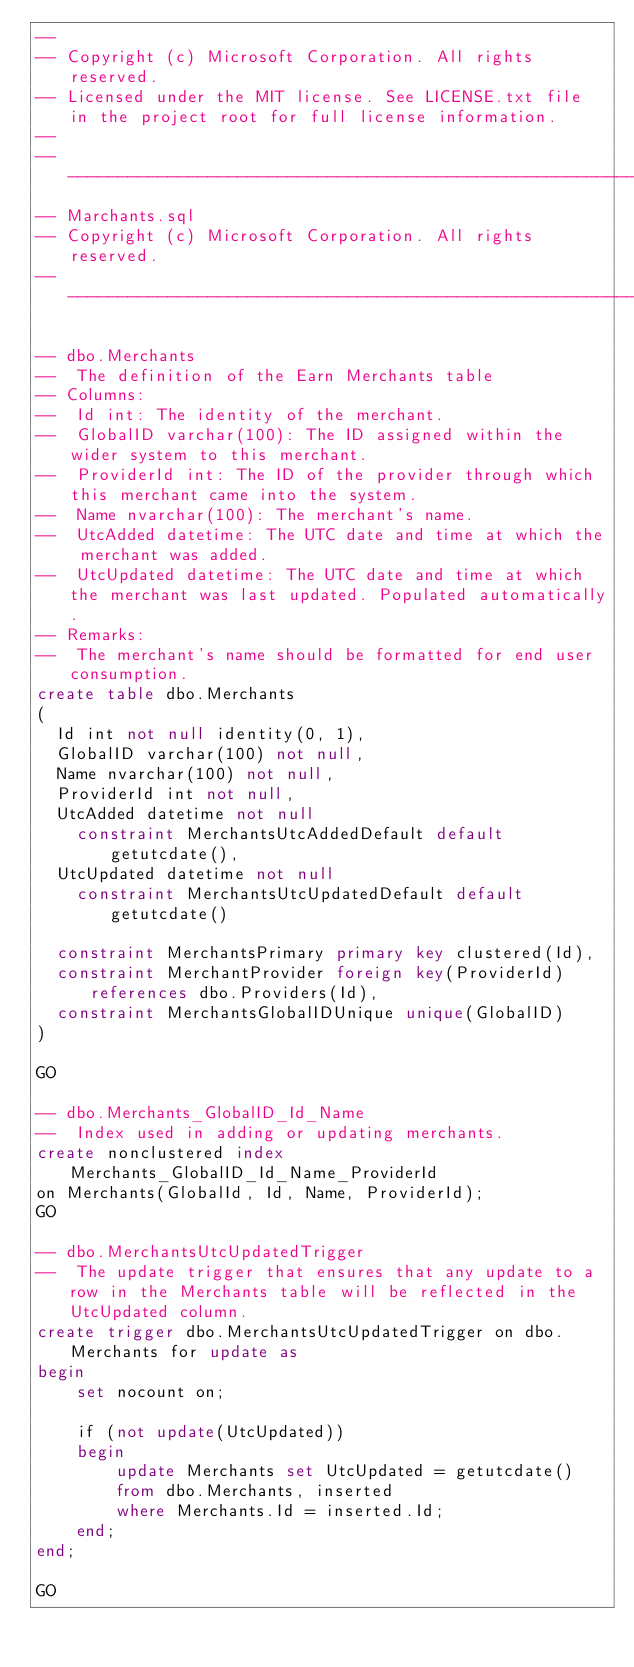Convert code to text. <code><loc_0><loc_0><loc_500><loc_500><_SQL_>--
-- Copyright (c) Microsoft Corporation. All rights reserved. 
-- Licensed under the MIT license. See LICENSE.txt file in the project root for full license information.
--
---------------------------------------------------------------------------------------------------------------------------------
-- Marchants.sql
-- Copyright (c) Microsoft Corporation. All rights reserved.  
---------------------------------------------------------------------------------------------------------------------------------

-- dbo.Merchants
--  The definition of the Earn Merchants table
-- Columns:
--  Id int: The identity of the merchant.
--  GlobalID varchar(100): The ID assigned within the wider system to this merchant.
--  ProviderId int: The ID of the provider through which this merchant came into the system.
--  Name nvarchar(100): The merchant's name.
--  UtcAdded datetime: The UTC date and time at which the merchant was added.
--  UtcUpdated datetime: The UTC date and time at which the merchant was last updated. Populated automatically.
-- Remarks:
--  The merchant's name should be formatted for end user consumption.
create table dbo.Merchants
(
	Id int not null identity(0, 1),
	GlobalID varchar(100) not null,
	Name nvarchar(100) not null,
  ProviderId int not null,
	UtcAdded datetime not null
		constraint MerchantsUtcAddedDefault default getutcdate(),
	UtcUpdated datetime not null
		constraint MerchantsUtcUpdatedDefault default getutcdate()

	constraint MerchantsPrimary primary key clustered(Id),
	constraint MerchantProvider foreign key(ProviderId) references dbo.Providers(Id),
	constraint MerchantsGlobalIDUnique unique(GlobalID)
)

GO

-- dbo.Merchants_GlobalID_Id_Name
--  Index used in adding or updating merchants.
create nonclustered index Merchants_GlobalID_Id_Name_ProviderId
on Merchants(GlobalId, Id, Name, ProviderId);
GO

-- dbo.MerchantsUtcUpdatedTrigger
--  The update trigger that ensures that any update to a row in the Merchants table will be reflected in the UtcUpdated column.
create trigger dbo.MerchantsUtcUpdatedTrigger on dbo.Merchants for update as
begin
    set nocount on;

    if (not update(UtcUpdated))
    begin
        update Merchants set UtcUpdated = getutcdate()
        from dbo.Merchants, inserted
        where Merchants.Id = inserted.Id;
    end;
end;

GO</code> 